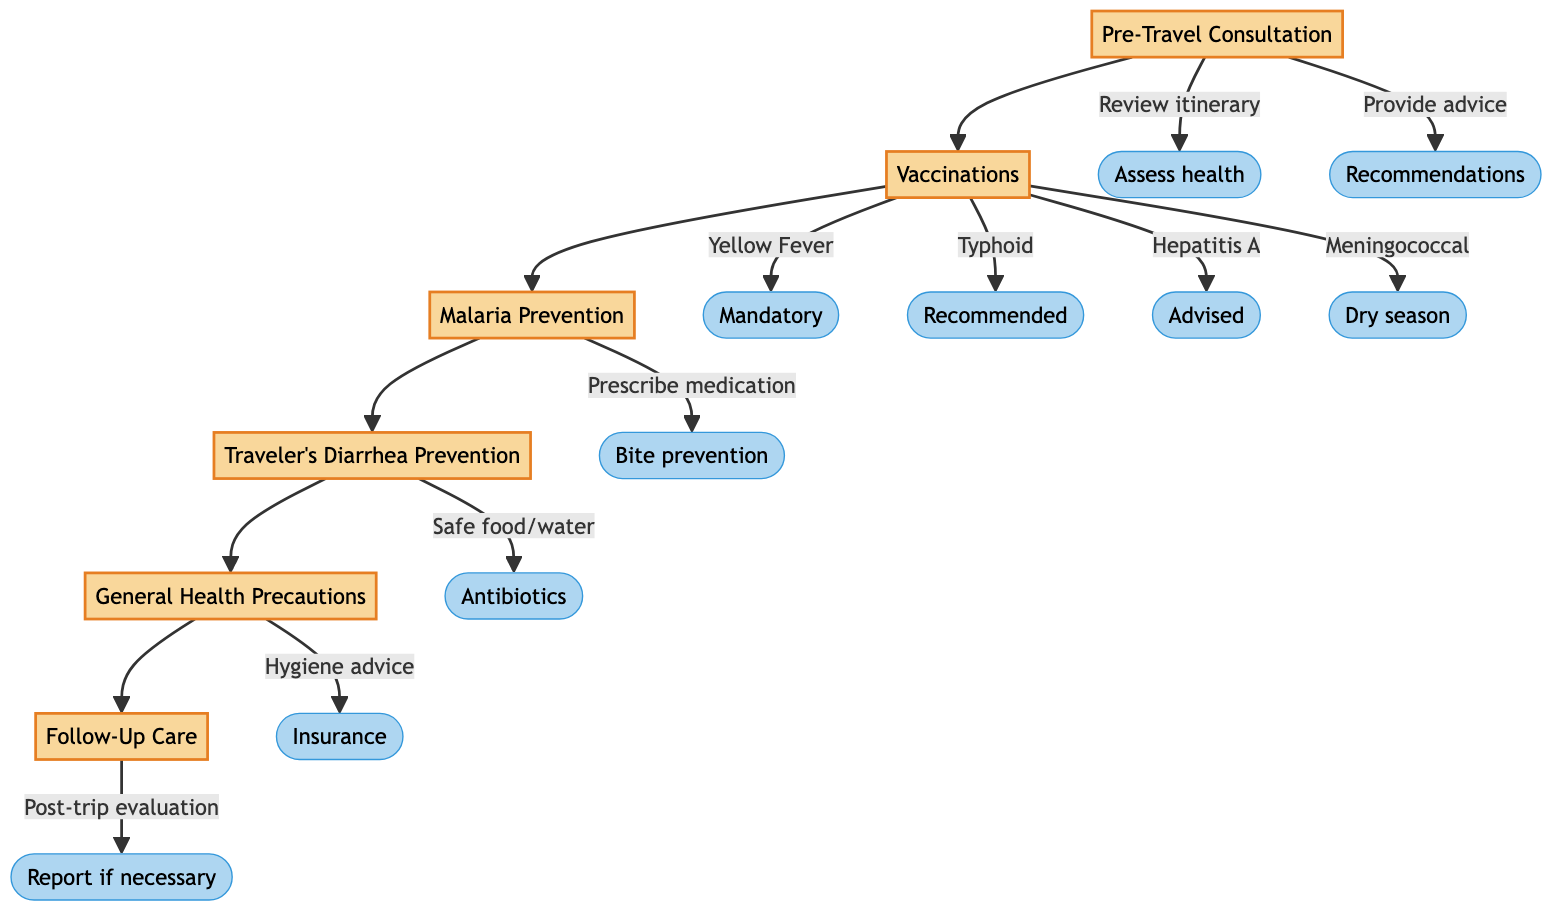What is the first step in the pathway? The first step in the pathway is "Pre-Travel Consultation." It is located at the beginning of the flowchart and outlines the initial action for tourists.
Answer: Pre-Travel Consultation How many vaccinations are listed in the diagram? There are four vaccinations mentioned in the "Vaccinations" step: Yellow Fever, Typhoid, Hepatitis A, and Meningococcal. Counting these reveals the total.
Answer: 4 What action is associated with Malaria Prevention? The action associated with Malaria Prevention includes "Prescribe antimalarial medication." It is specified under the Malaria Prevention step.
Answer: Prescribe antimalarial medication What is recommended during the dry season? The vaccination note specifies that "Meningococcal" vaccination is particularly advised during the dry season, which covers the months of December to June.
Answer: Meningococcal Which step comes after Traveler's Diarrhea Prevention? The step following Traveler's Diarrhea Prevention is "General Health Precautions." This progression is visually represented in the flowchart.
Answer: General Health Precautions What should be done post-trip in the Follow-Up Care step? In the Follow-Up Care step, it is necessary to "Schedule a follow-up appointment after returning." This action is crucial for post-travel health evaluation.
Answer: Schedule a follow-up appointment Name one action included in the General Health Precautions step. One action listed in the General Health Precautions step is "Advise on personal hygiene and avoiding contact with animals," which promotes health safety for travelers.
Answer: Advise on personal hygiene Which vaccination is mandatory? The mandatory vaccination for all travelers over 9 months old is "Yellow Fever." This requirement is explicitly noted under the Vaccinations step.
Answer: Yellow Fever What is advised for treating severe cases of traveler's diarrhea? For treating severe cases of traveler's diarrhea, the diagram advises the use of "Ciprofloxacin" antibiotics, as stated in the Traveler's Diarrhea Prevention step.
Answer: Ciprofloxacin 